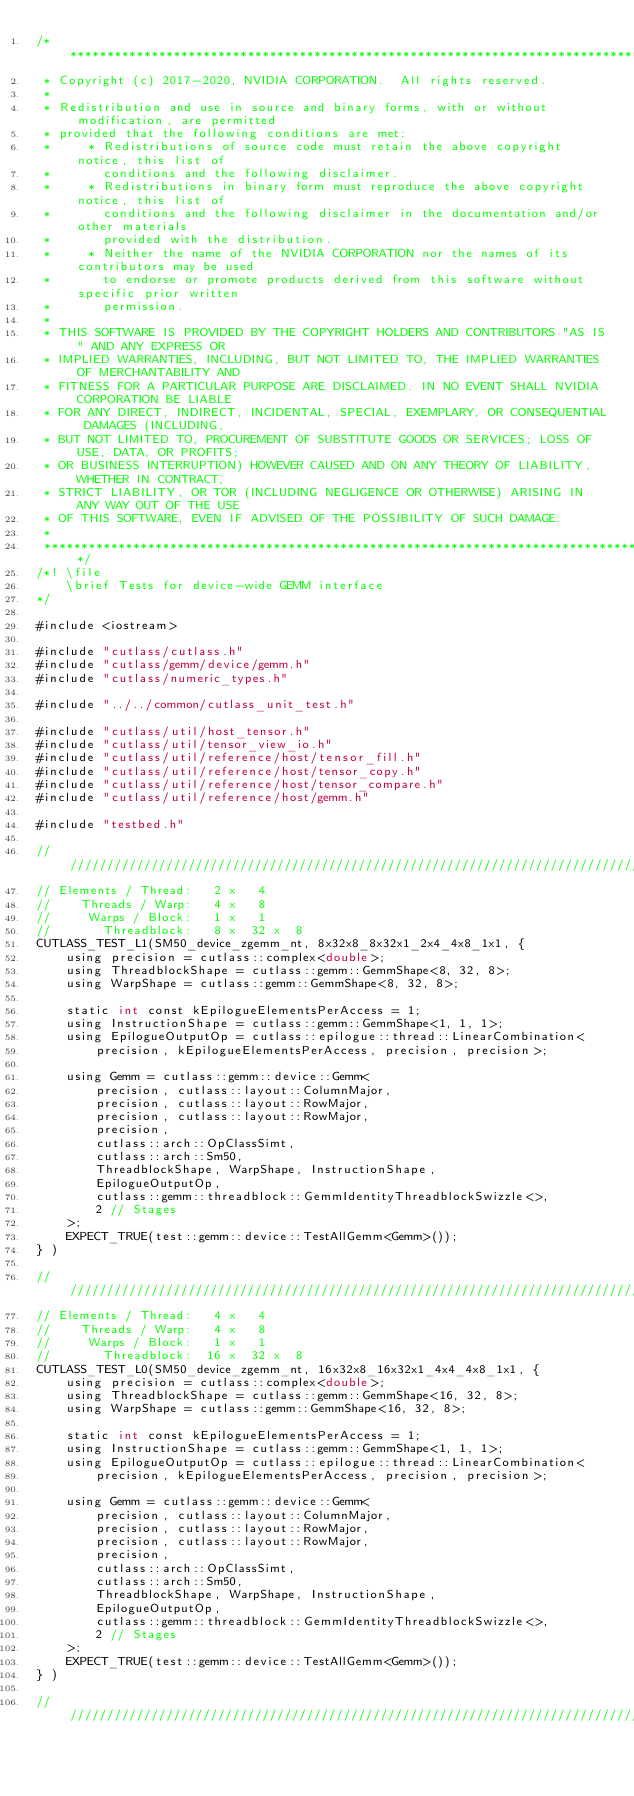Convert code to text. <code><loc_0><loc_0><loc_500><loc_500><_Cuda_>/***************************************************************************************************
 * Copyright (c) 2017-2020, NVIDIA CORPORATION.  All rights reserved.
 *
 * Redistribution and use in source and binary forms, with or without modification, are permitted
 * provided that the following conditions are met:
 *     * Redistributions of source code must retain the above copyright notice, this list of
 *       conditions and the following disclaimer.
 *     * Redistributions in binary form must reproduce the above copyright notice, this list of
 *       conditions and the following disclaimer in the documentation and/or other materials
 *       provided with the distribution.
 *     * Neither the name of the NVIDIA CORPORATION nor the names of its contributors may be used
 *       to endorse or promote products derived from this software without specific prior written
 *       permission.
 *
 * THIS SOFTWARE IS PROVIDED BY THE COPYRIGHT HOLDERS AND CONTRIBUTORS "AS IS" AND ANY EXPRESS OR
 * IMPLIED WARRANTIES, INCLUDING, BUT NOT LIMITED TO, THE IMPLIED WARRANTIES OF MERCHANTABILITY AND
 * FITNESS FOR A PARTICULAR PURPOSE ARE DISCLAIMED. IN NO EVENT SHALL NVIDIA CORPORATION BE LIABLE
 * FOR ANY DIRECT, INDIRECT, INCIDENTAL, SPECIAL, EXEMPLARY, OR CONSEQUENTIAL DAMAGES (INCLUDING,
 * BUT NOT LIMITED TO, PROCUREMENT OF SUBSTITUTE GOODS OR SERVICES; LOSS OF USE, DATA, OR PROFITS;
 * OR BUSINESS INTERRUPTION) HOWEVER CAUSED AND ON ANY THEORY OF LIABILITY, WHETHER IN CONTRACT,
 * STRICT LIABILITY, OR TOR (INCLUDING NEGLIGENCE OR OTHERWISE) ARISING IN ANY WAY OUT OF THE USE
 * OF THIS SOFTWARE, EVEN IF ADVISED OF THE POSSIBILITY OF SUCH DAMAGE.
 *
 **************************************************************************************************/
/*! \file
    \brief Tests for device-wide GEMM interface
*/

#include <iostream>

#include "cutlass/cutlass.h"
#include "cutlass/gemm/device/gemm.h"
#include "cutlass/numeric_types.h"

#include "../../common/cutlass_unit_test.h"

#include "cutlass/util/host_tensor.h"
#include "cutlass/util/tensor_view_io.h"
#include "cutlass/util/reference/host/tensor_fill.h"
#include "cutlass/util/reference/host/tensor_copy.h"
#include "cutlass/util/reference/host/tensor_compare.h"
#include "cutlass/util/reference/host/gemm.h"

#include "testbed.h"

////////////////////////////////////////////////////////////////////////////////
// Elements / Thread:   2 x   4
//    Threads / Warp:   4 x   8
//     Warps / Block:   1 x   1
//       Threadblock:   8 x  32 x  8
CUTLASS_TEST_L1(SM50_device_zgemm_nt, 8x32x8_8x32x1_2x4_4x8_1x1, {
    using precision = cutlass::complex<double>;
    using ThreadblockShape = cutlass::gemm::GemmShape<8, 32, 8>;
    using WarpShape = cutlass::gemm::GemmShape<8, 32, 8>;

    static int const kEpilogueElementsPerAccess = 1;
    using InstructionShape = cutlass::gemm::GemmShape<1, 1, 1>;
    using EpilogueOutputOp = cutlass::epilogue::thread::LinearCombination<
        precision, kEpilogueElementsPerAccess, precision, precision>;

    using Gemm = cutlass::gemm::device::Gemm<
        precision, cutlass::layout::ColumnMajor,
        precision, cutlass::layout::RowMajor,
        precision, cutlass::layout::RowMajor,
        precision,
        cutlass::arch::OpClassSimt,
        cutlass::arch::Sm50,
        ThreadblockShape, WarpShape, InstructionShape,
        EpilogueOutputOp,
        cutlass::gemm::threadblock::GemmIdentityThreadblockSwizzle<>,
        2 // Stages
    >;
    EXPECT_TRUE(test::gemm::device::TestAllGemm<Gemm>());
} )

////////////////////////////////////////////////////////////////////////////////
// Elements / Thread:   4 x   4
//    Threads / Warp:   4 x   8
//     Warps / Block:   1 x   1
//       Threadblock:  16 x  32 x  8
CUTLASS_TEST_L0(SM50_device_zgemm_nt, 16x32x8_16x32x1_4x4_4x8_1x1, {
    using precision = cutlass::complex<double>;
    using ThreadblockShape = cutlass::gemm::GemmShape<16, 32, 8>;
    using WarpShape = cutlass::gemm::GemmShape<16, 32, 8>;

    static int const kEpilogueElementsPerAccess = 1;
    using InstructionShape = cutlass::gemm::GemmShape<1, 1, 1>;
    using EpilogueOutputOp = cutlass::epilogue::thread::LinearCombination<
        precision, kEpilogueElementsPerAccess, precision, precision>;

    using Gemm = cutlass::gemm::device::Gemm<
        precision, cutlass::layout::ColumnMajor,
        precision, cutlass::layout::RowMajor,
        precision, cutlass::layout::RowMajor,
        precision,
        cutlass::arch::OpClassSimt,
        cutlass::arch::Sm50,
        ThreadblockShape, WarpShape, InstructionShape,
        EpilogueOutputOp,
        cutlass::gemm::threadblock::GemmIdentityThreadblockSwizzle<>,
        2 // Stages
    >;
    EXPECT_TRUE(test::gemm::device::TestAllGemm<Gemm>());
} )

////////////////////////////////////////////////////////////////////////////////</code> 